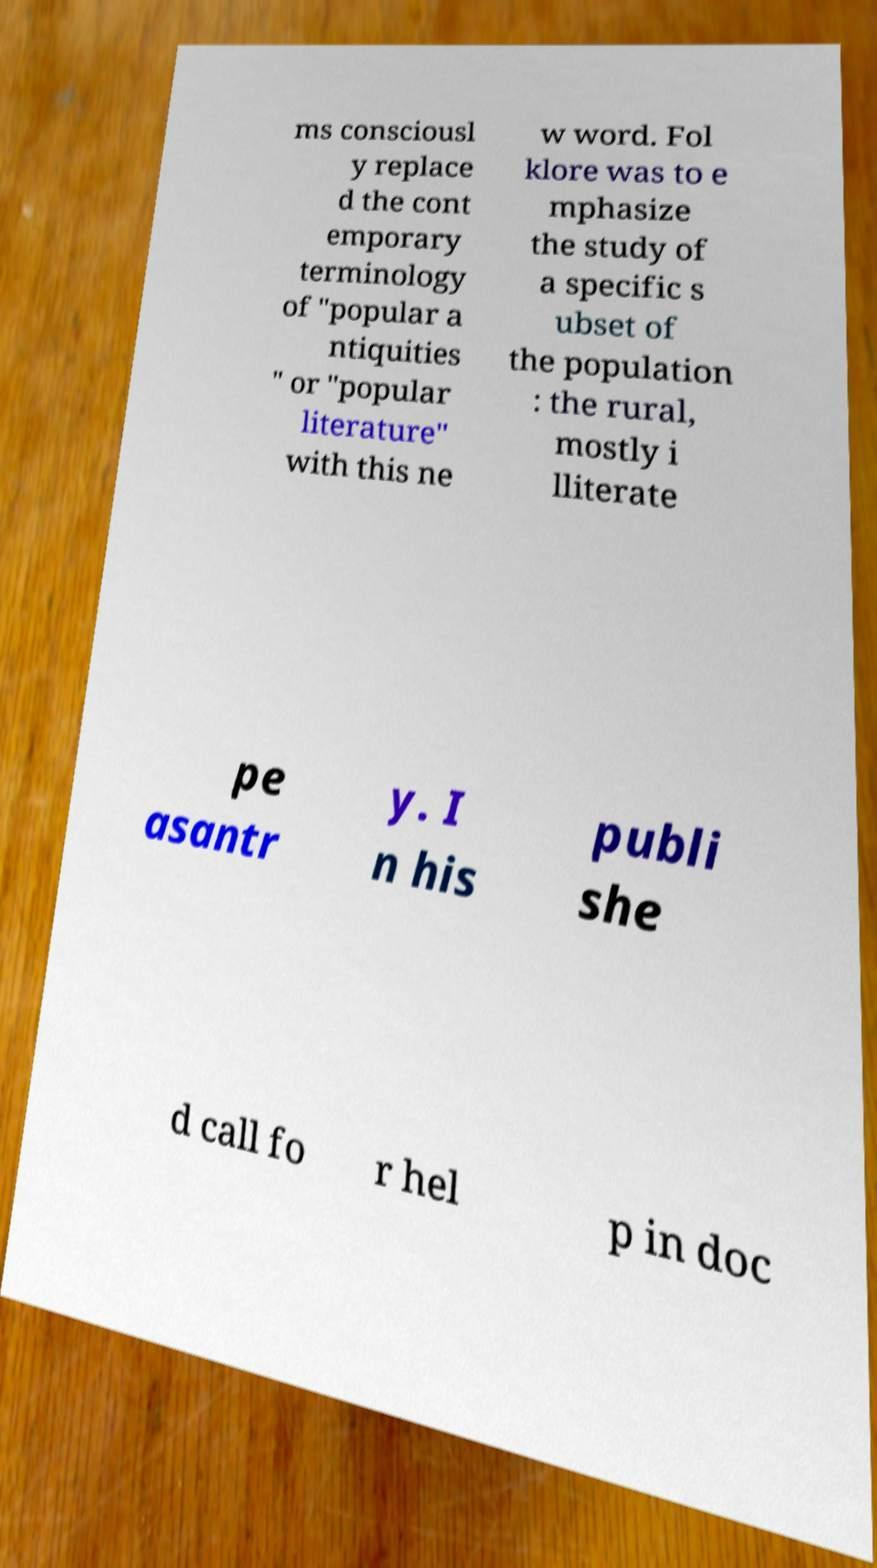Could you extract and type out the text from this image? ms consciousl y replace d the cont emporary terminology of "popular a ntiquities " or "popular literature" with this ne w word. Fol klore was to e mphasize the study of a specific s ubset of the population : the rural, mostly i lliterate pe asantr y. I n his publi she d call fo r hel p in doc 